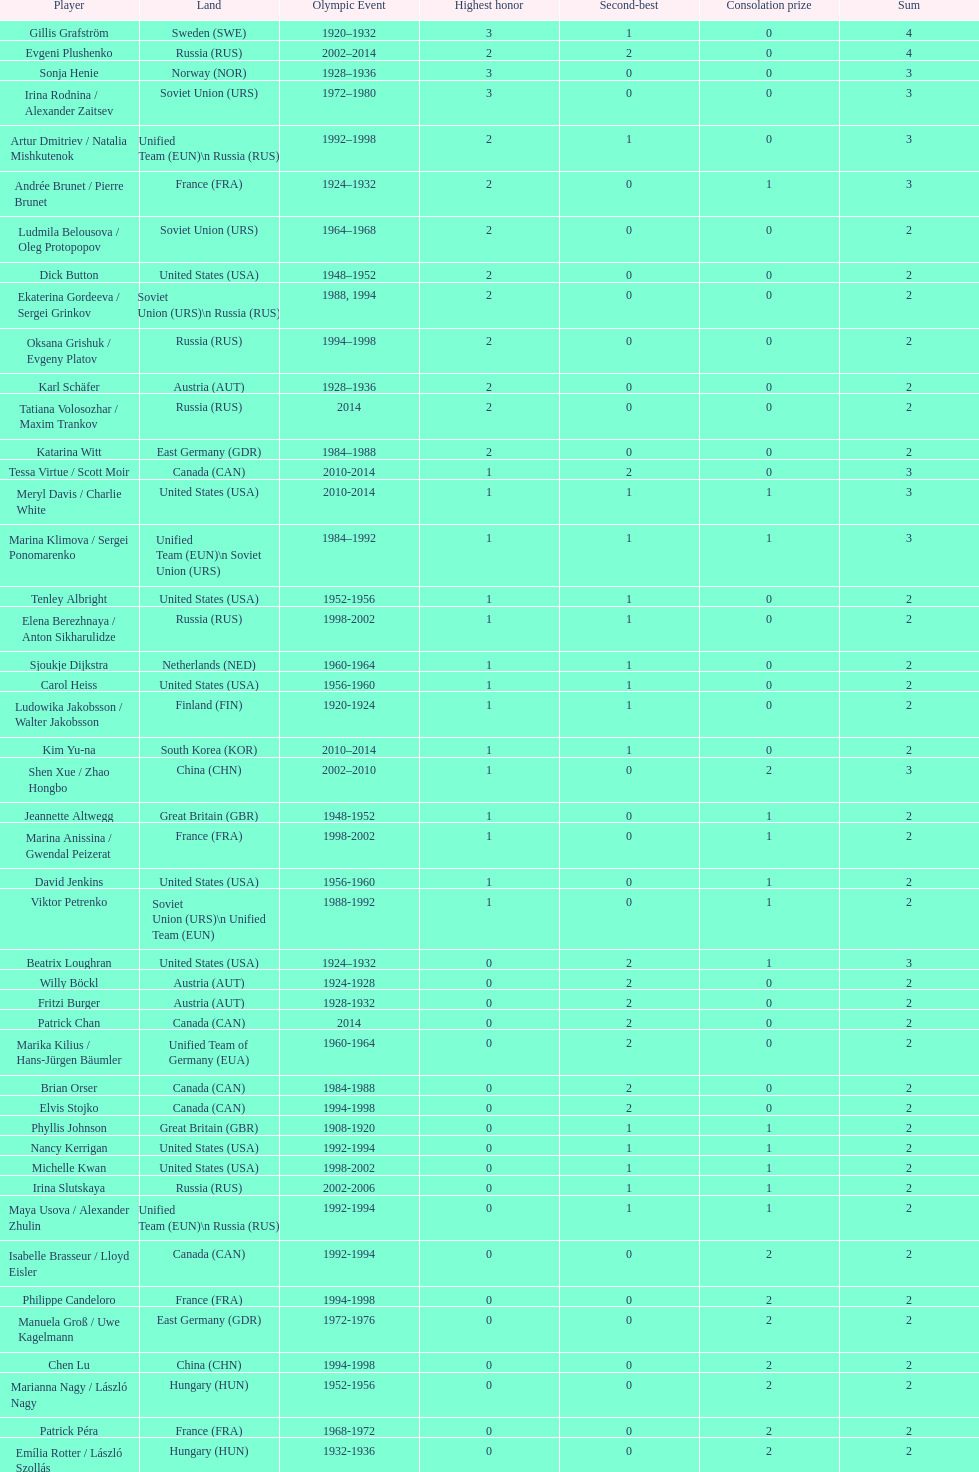How many total medals has the united states won in women's figure skating? 16. 